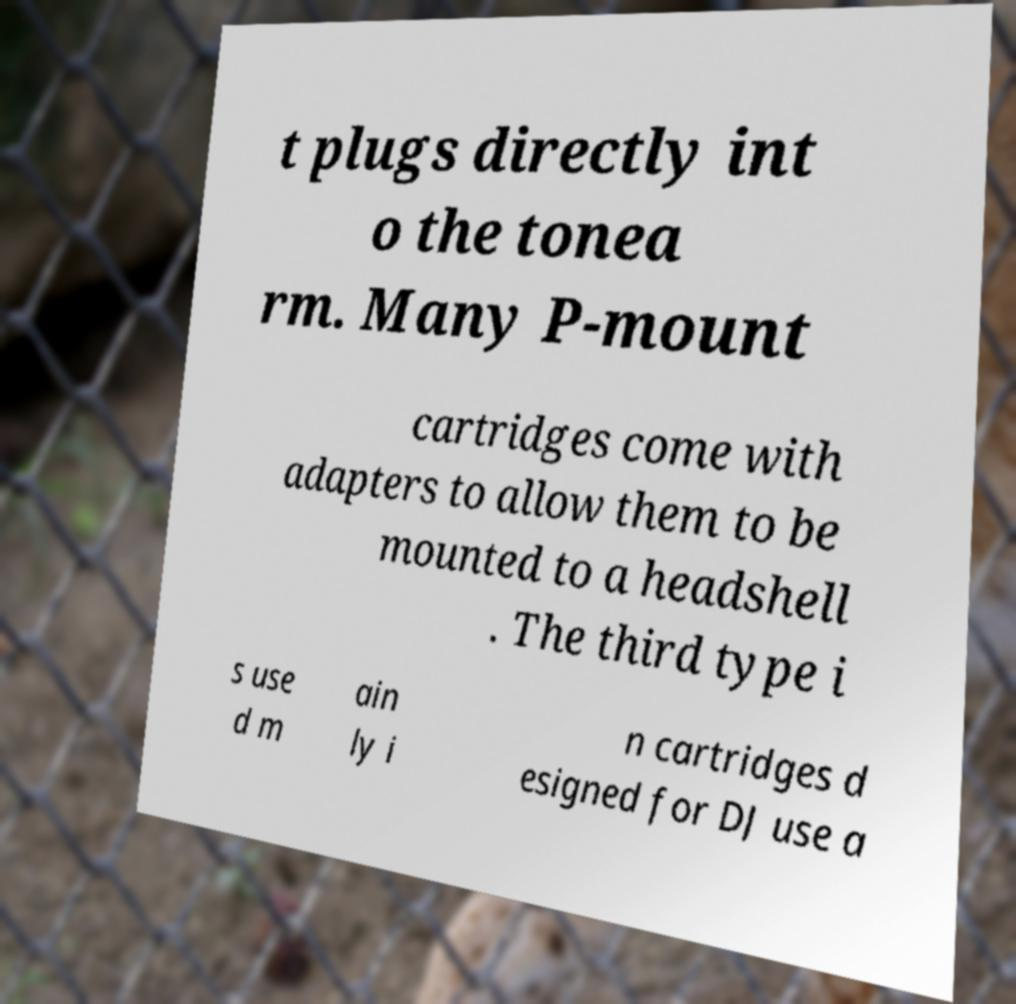Can you read and provide the text displayed in the image?This photo seems to have some interesting text. Can you extract and type it out for me? t plugs directly int o the tonea rm. Many P-mount cartridges come with adapters to allow them to be mounted to a headshell . The third type i s use d m ain ly i n cartridges d esigned for DJ use a 